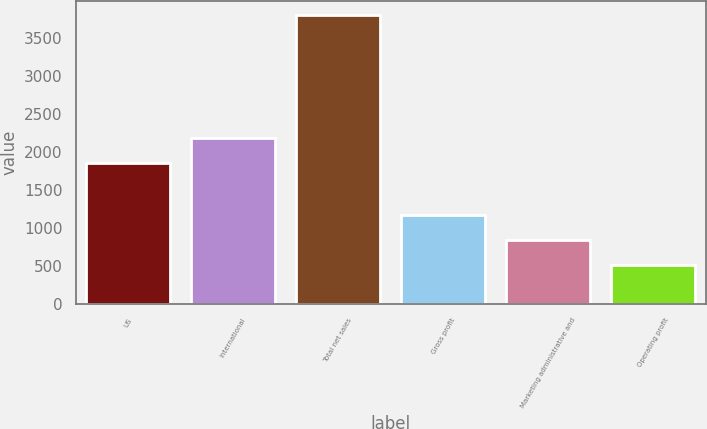<chart> <loc_0><loc_0><loc_500><loc_500><bar_chart><fcel>US<fcel>International<fcel>Total net sales<fcel>Gross profit<fcel>Marketing administrative and<fcel>Operating profit<nl><fcel>1851.8<fcel>2181.31<fcel>3798.1<fcel>1162.1<fcel>832.51<fcel>503<nl></chart> 